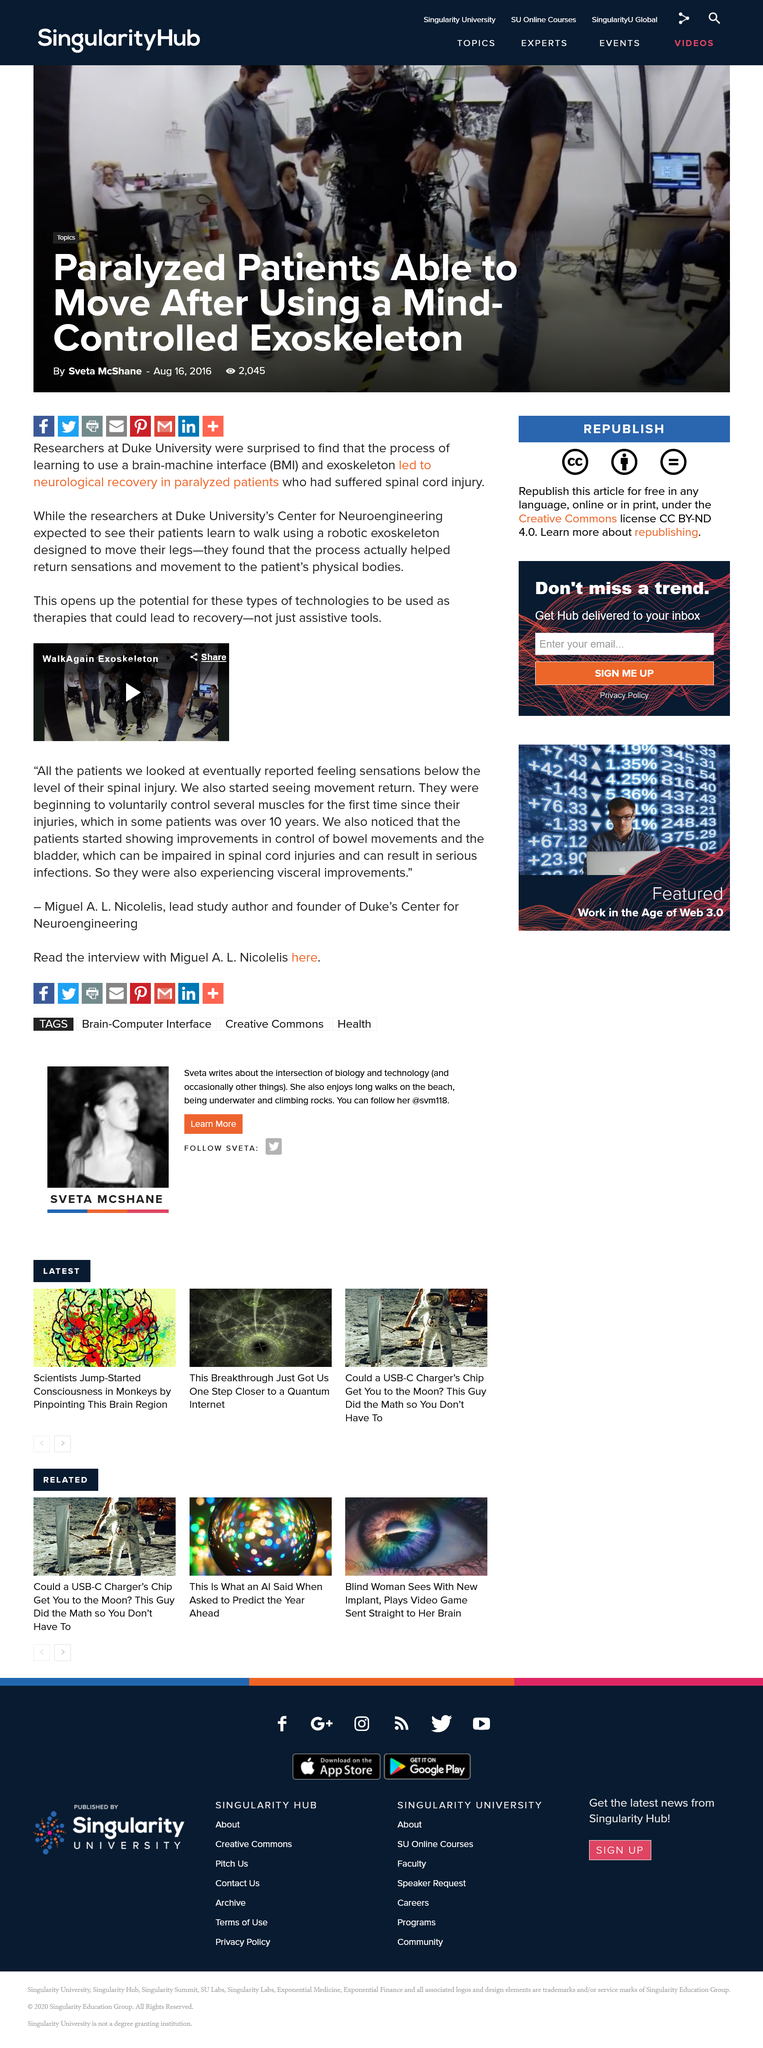Specify some key components in this picture. Patients demonstrated improvements in their control of bowel movements, as observed by the researchers. In conclusion, exoskeletons are a technology that can aid in the recovery process of individuals who have suffered from spinal injuries. These advanced machines are designed to be worn like a suit and provide support and assistance to the wearer's limbs, allowing them to regain mobility and strength in their affected spinal regions. The use of exoskeletons has been shown to help individuals recover from spinal injuries and improve their overall physical functioning and quality of life. All patients reported feeling sensations, with the majority reporting sensations below the level of their spinal injury. 